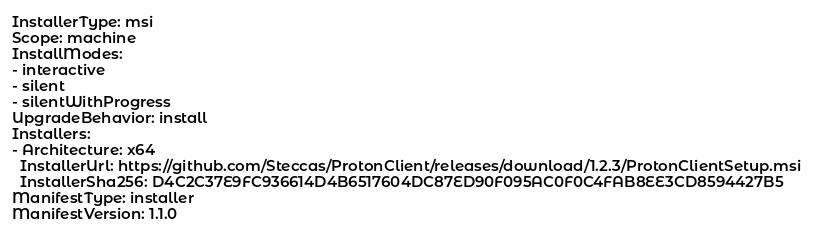Convert code to text. <code><loc_0><loc_0><loc_500><loc_500><_YAML_>InstallerType: msi
Scope: machine
InstallModes:
- interactive
- silent
- silentWithProgress
UpgradeBehavior: install
Installers:
- Architecture: x64
  InstallerUrl: https://github.com/Steccas/ProtonClient/releases/download/1.2.3/ProtonClientSetup.msi
  InstallerSha256: D4C2C37E9FC936614D4B6517604DC87ED90F095AC0F0C4FAB8EE3CD8594427B5
ManifestType: installer
ManifestVersion: 1.1.0
</code> 